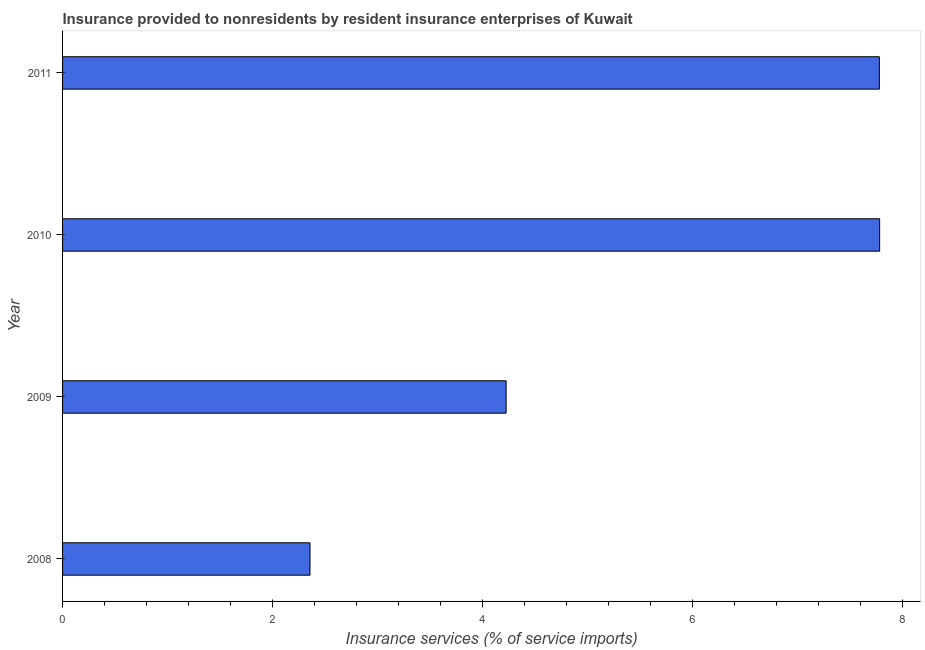Does the graph contain any zero values?
Provide a short and direct response. No. What is the title of the graph?
Your answer should be compact. Insurance provided to nonresidents by resident insurance enterprises of Kuwait. What is the label or title of the X-axis?
Your response must be concise. Insurance services (% of service imports). What is the insurance and financial services in 2011?
Offer a very short reply. 7.78. Across all years, what is the maximum insurance and financial services?
Your answer should be compact. 7.79. Across all years, what is the minimum insurance and financial services?
Give a very brief answer. 2.36. In which year was the insurance and financial services maximum?
Keep it short and to the point. 2010. In which year was the insurance and financial services minimum?
Provide a short and direct response. 2008. What is the sum of the insurance and financial services?
Provide a short and direct response. 22.15. What is the difference between the insurance and financial services in 2010 and 2011?
Give a very brief answer. 0. What is the average insurance and financial services per year?
Your response must be concise. 5.54. What is the median insurance and financial services?
Give a very brief answer. 6.01. Do a majority of the years between 2008 and 2011 (inclusive) have insurance and financial services greater than 6 %?
Your response must be concise. No. What is the ratio of the insurance and financial services in 2009 to that in 2011?
Provide a short and direct response. 0.54. Is the insurance and financial services in 2009 less than that in 2010?
Give a very brief answer. Yes. Is the difference between the insurance and financial services in 2009 and 2010 greater than the difference between any two years?
Offer a terse response. No. What is the difference between the highest and the second highest insurance and financial services?
Your answer should be very brief. 0. Is the sum of the insurance and financial services in 2010 and 2011 greater than the maximum insurance and financial services across all years?
Your answer should be compact. Yes. What is the difference between the highest and the lowest insurance and financial services?
Ensure brevity in your answer.  5.43. In how many years, is the insurance and financial services greater than the average insurance and financial services taken over all years?
Ensure brevity in your answer.  2. How many bars are there?
Give a very brief answer. 4. Are all the bars in the graph horizontal?
Provide a succinct answer. Yes. Are the values on the major ticks of X-axis written in scientific E-notation?
Provide a succinct answer. No. What is the Insurance services (% of service imports) in 2008?
Keep it short and to the point. 2.36. What is the Insurance services (% of service imports) of 2009?
Offer a very short reply. 4.23. What is the Insurance services (% of service imports) of 2010?
Your response must be concise. 7.79. What is the Insurance services (% of service imports) in 2011?
Provide a succinct answer. 7.78. What is the difference between the Insurance services (% of service imports) in 2008 and 2009?
Offer a terse response. -1.87. What is the difference between the Insurance services (% of service imports) in 2008 and 2010?
Provide a short and direct response. -5.43. What is the difference between the Insurance services (% of service imports) in 2008 and 2011?
Give a very brief answer. -5.43. What is the difference between the Insurance services (% of service imports) in 2009 and 2010?
Offer a very short reply. -3.56. What is the difference between the Insurance services (% of service imports) in 2009 and 2011?
Ensure brevity in your answer.  -3.56. What is the difference between the Insurance services (% of service imports) in 2010 and 2011?
Ensure brevity in your answer.  0. What is the ratio of the Insurance services (% of service imports) in 2008 to that in 2009?
Keep it short and to the point. 0.56. What is the ratio of the Insurance services (% of service imports) in 2008 to that in 2010?
Your answer should be very brief. 0.3. What is the ratio of the Insurance services (% of service imports) in 2008 to that in 2011?
Make the answer very short. 0.3. What is the ratio of the Insurance services (% of service imports) in 2009 to that in 2010?
Your answer should be very brief. 0.54. What is the ratio of the Insurance services (% of service imports) in 2009 to that in 2011?
Keep it short and to the point. 0.54. 